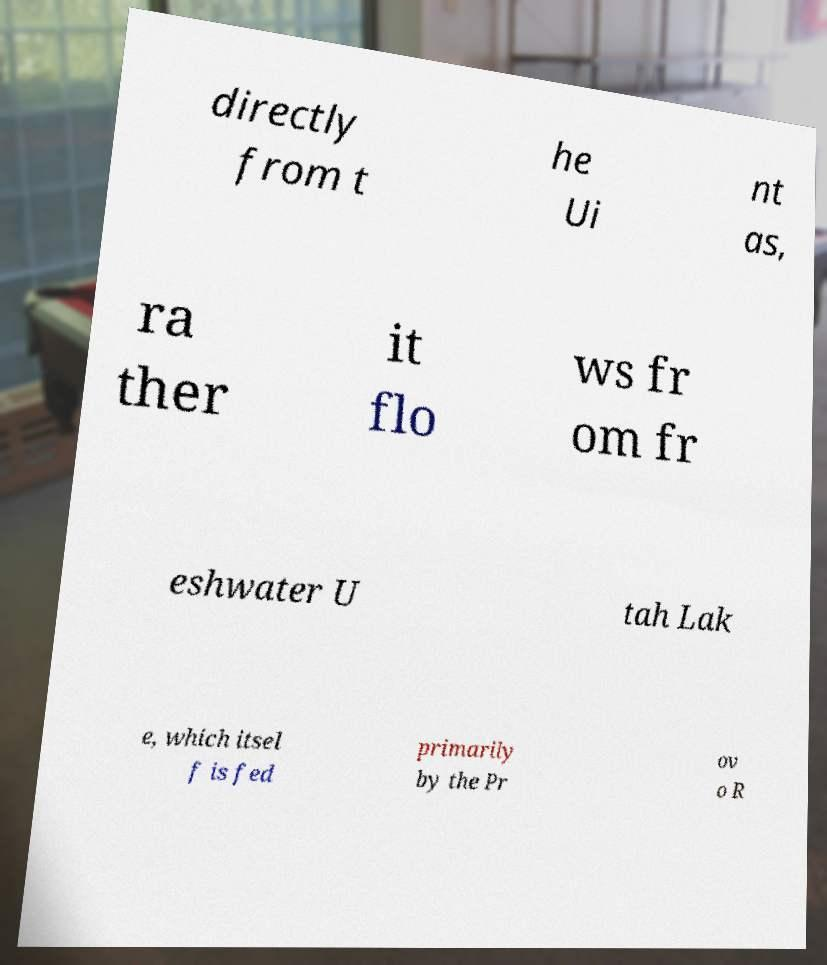Please read and relay the text visible in this image. What does it say? directly from t he Ui nt as, ra ther it flo ws fr om fr eshwater U tah Lak e, which itsel f is fed primarily by the Pr ov o R 